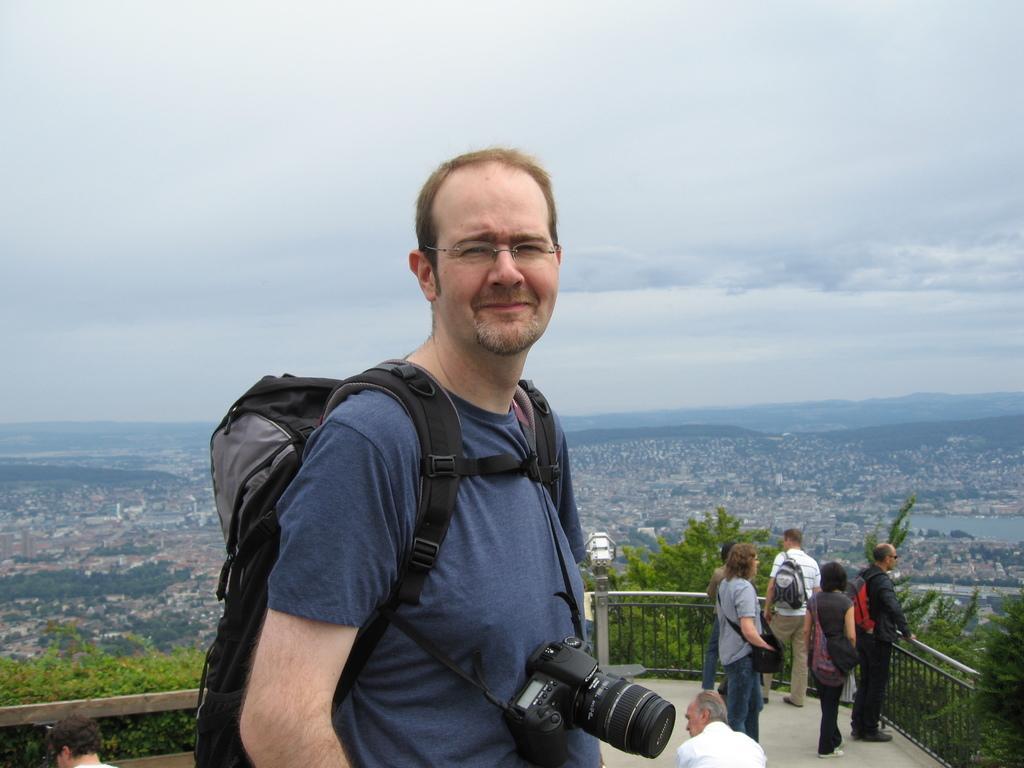Describe this image in one or two sentences. In the foreground of the picture there is a person wearing a backpack and camera. In the center of the picture there are people, trees, plants, light and railing. In the background it is aerial view of a city. In the background there are trees, buildings and hills. Sky is cloudy. 